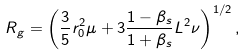Convert formula to latex. <formula><loc_0><loc_0><loc_500><loc_500>R _ { g } = \left ( \frac { 3 } { 5 } r _ { 0 } ^ { 2 } \mu + 3 \frac { 1 - \beta _ { s } } { 1 + \beta _ { s } } { L } ^ { 2 } \nu \right ) ^ { 1 / 2 } ,</formula> 